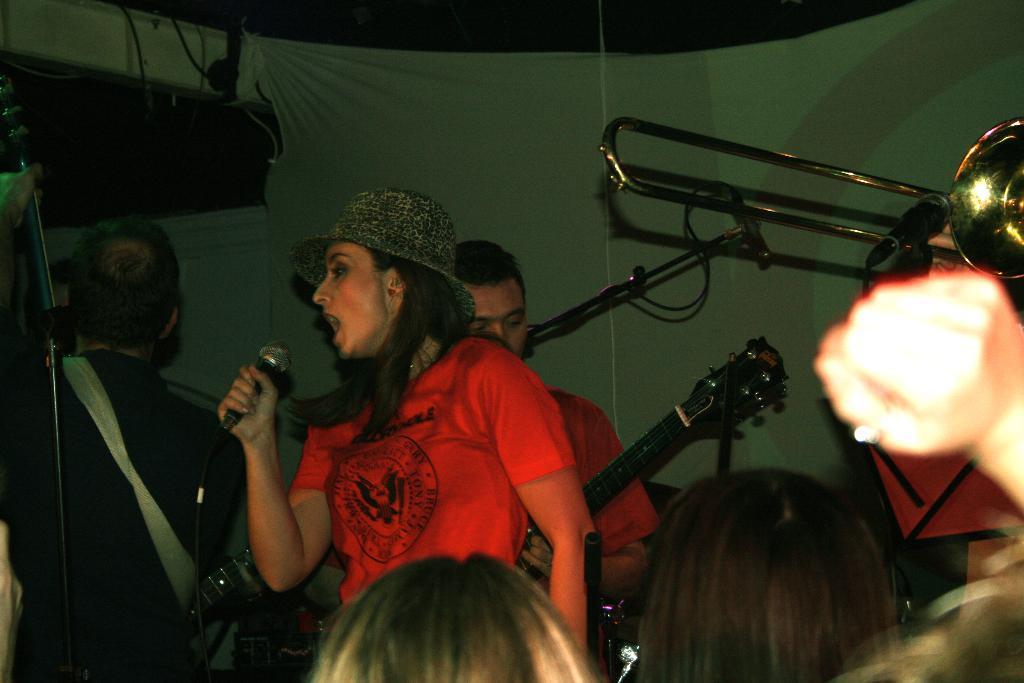In one or two sentences, can you explain what this image depicts? In this picture we can see a woman who is singing on the mike. She wear a cap and on the background there are two persons. And they are playing guitar. 